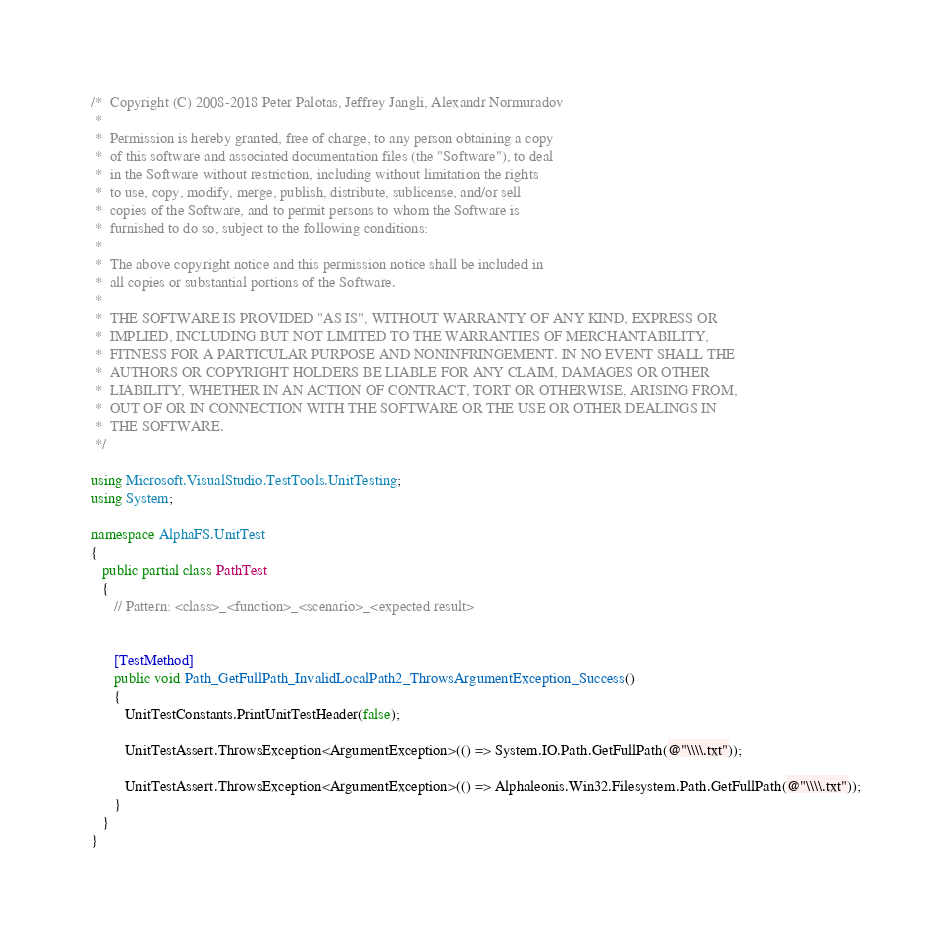Convert code to text. <code><loc_0><loc_0><loc_500><loc_500><_C#_>/*  Copyright (C) 2008-2018 Peter Palotas, Jeffrey Jangli, Alexandr Normuradov
 *  
 *  Permission is hereby granted, free of charge, to any person obtaining a copy 
 *  of this software and associated documentation files (the "Software"), to deal 
 *  in the Software without restriction, including without limitation the rights 
 *  to use, copy, modify, merge, publish, distribute, sublicense, and/or sell 
 *  copies of the Software, and to permit persons to whom the Software is 
 *  furnished to do so, subject to the following conditions:
 *  
 *  The above copyright notice and this permission notice shall be included in 
 *  all copies or substantial portions of the Software.
 *  
 *  THE SOFTWARE IS PROVIDED "AS IS", WITHOUT WARRANTY OF ANY KIND, EXPRESS OR 
 *  IMPLIED, INCLUDING BUT NOT LIMITED TO THE WARRANTIES OF MERCHANTABILITY, 
 *  FITNESS FOR A PARTICULAR PURPOSE AND NONINFRINGEMENT. IN NO EVENT SHALL THE 
 *  AUTHORS OR COPYRIGHT HOLDERS BE LIABLE FOR ANY CLAIM, DAMAGES OR OTHER 
 *  LIABILITY, WHETHER IN AN ACTION OF CONTRACT, TORT OR OTHERWISE, ARISING FROM, 
 *  OUT OF OR IN CONNECTION WITH THE SOFTWARE OR THE USE OR OTHER DEALINGS IN 
 *  THE SOFTWARE. 
 */

using Microsoft.VisualStudio.TestTools.UnitTesting;
using System;

namespace AlphaFS.UnitTest
{
   public partial class PathTest
   {
      // Pattern: <class>_<function>_<scenario>_<expected result>


      [TestMethod]
      public void Path_GetFullPath_InvalidLocalPath2_ThrowsArgumentException_Success()
      {
         UnitTestConstants.PrintUnitTestHeader(false);

         UnitTestAssert.ThrowsException<ArgumentException>(() => System.IO.Path.GetFullPath(@"\\\\.txt"));

         UnitTestAssert.ThrowsException<ArgumentException>(() => Alphaleonis.Win32.Filesystem.Path.GetFullPath(@"\\\\.txt"));
      }
   }
}
</code> 